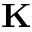Convert formula to latex. <formula><loc_0><loc_0><loc_500><loc_500>K</formula> 